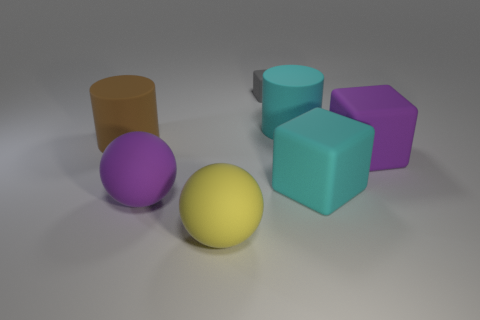Subtract all gray cubes. How many cubes are left? 2 Add 3 tiny gray objects. How many objects exist? 10 Subtract all purple spheres. How many spheres are left? 1 Subtract all balls. How many objects are left? 5 Subtract 2 blocks. How many blocks are left? 1 Subtract 0 red cubes. How many objects are left? 7 Subtract all gray blocks. Subtract all yellow spheres. How many blocks are left? 2 Subtract all small gray metallic cubes. Subtract all gray things. How many objects are left? 6 Add 1 large matte spheres. How many large matte spheres are left? 3 Add 5 small brown blocks. How many small brown blocks exist? 5 